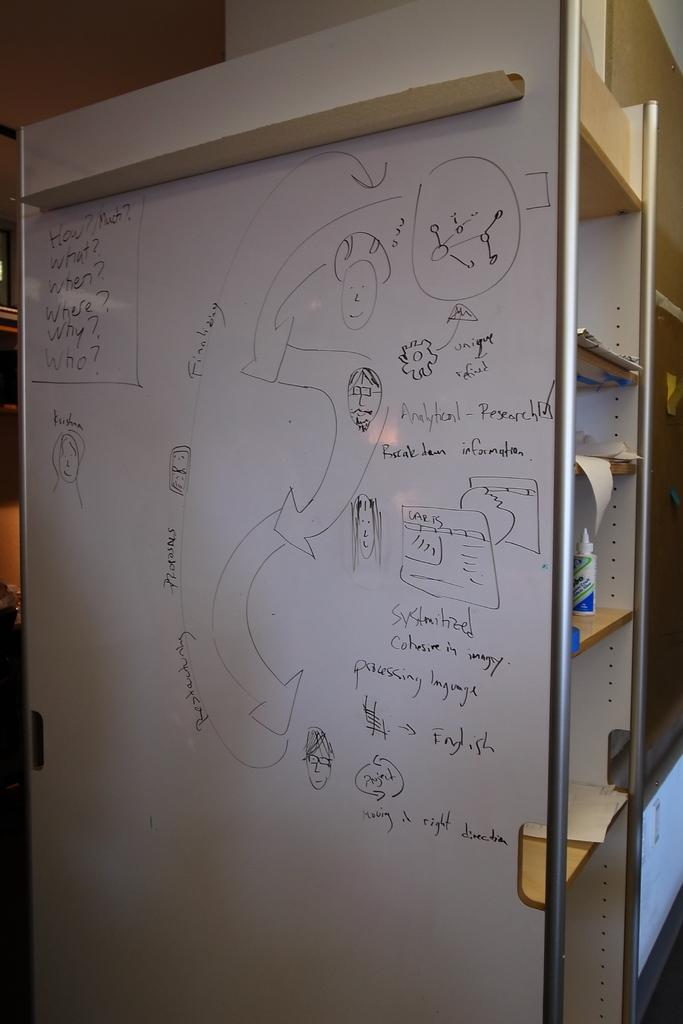What is the main object in the image? There is a board in the image. What is the color of the board? The board is white in color. What is written on the board? There is writing on the board in black color. What can be seen in the background of the image? The background of the image includes wooden racks. How many dolls are sitting on the wooden racks in the image? There are no dolls present in the image; it only features a white board with black writing and wooden racks in the background. 